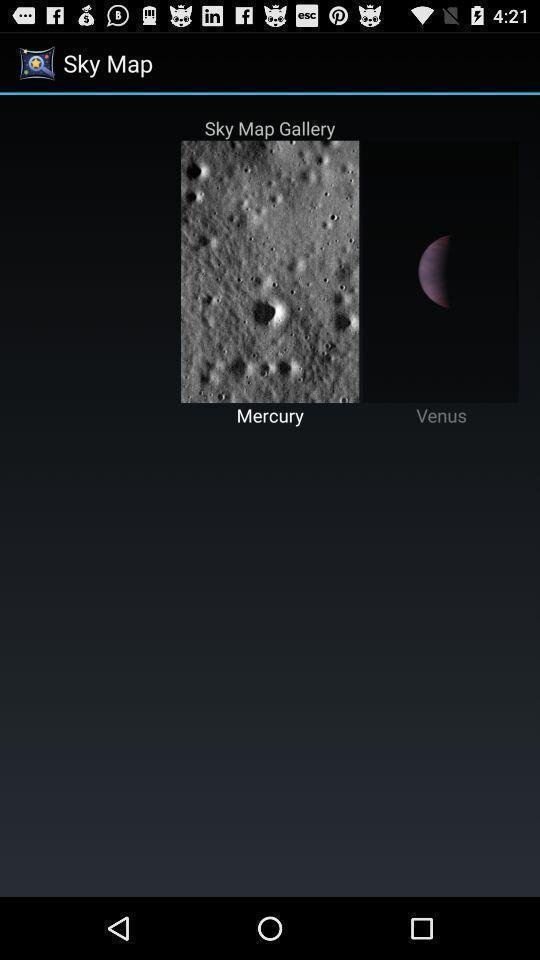Provide a description of this screenshot. Sky map gallery in the sky map. 